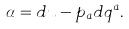Convert formula to latex. <formula><loc_0><loc_0><loc_500><loc_500>\alpha = d u - p _ { a } d q ^ { a } .</formula> 